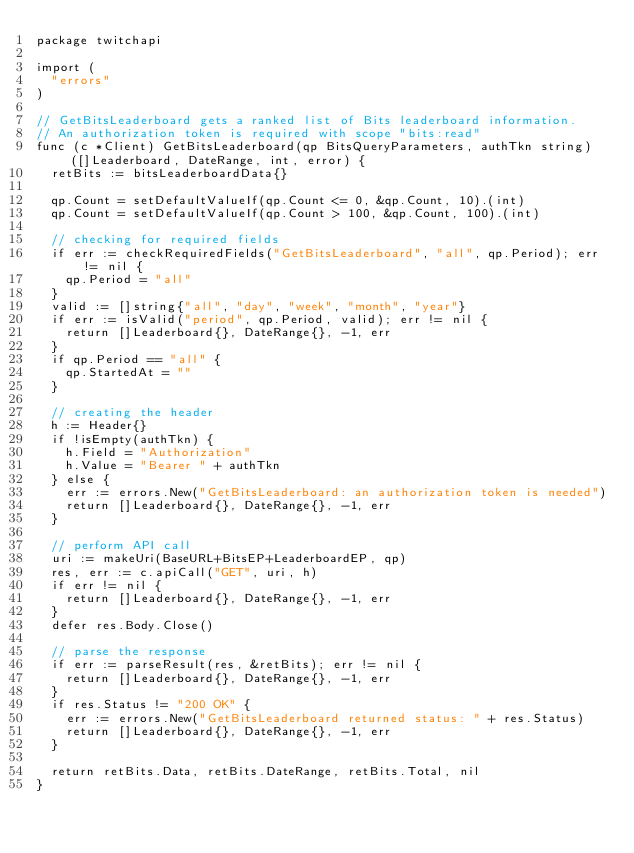<code> <loc_0><loc_0><loc_500><loc_500><_Go_>package twitchapi

import (
	"errors"
)

// GetBitsLeaderboard gets a ranked list of Bits leaderboard information.
// An authorization token is required with scope "bits:read"
func (c *Client) GetBitsLeaderboard(qp BitsQueryParameters, authTkn string) ([]Leaderboard, DateRange, int, error) {
	retBits := bitsLeaderboardData{}

	qp.Count = setDefaultValueIf(qp.Count <= 0, &qp.Count, 10).(int)
	qp.Count = setDefaultValueIf(qp.Count > 100, &qp.Count, 100).(int)

	// checking for required fields
	if err := checkRequiredFields("GetBitsLeaderboard", "all", qp.Period); err != nil {
		qp.Period = "all"
	}
	valid := []string{"all", "day", "week", "month", "year"}
	if err := isValid("period", qp.Period, valid); err != nil {
		return []Leaderboard{}, DateRange{}, -1, err
	}
	if qp.Period == "all" {
		qp.StartedAt = ""
	}

	// creating the header
	h := Header{}
	if !isEmpty(authTkn) {
		h.Field = "Authorization"
		h.Value = "Bearer " + authTkn
	} else {
		err := errors.New("GetBitsLeaderboard: an authorization token is needed")
		return []Leaderboard{}, DateRange{}, -1, err
	}

	// perform API call
	uri := makeUri(BaseURL+BitsEP+LeaderboardEP, qp)
	res, err := c.apiCall("GET", uri, h)
	if err != nil {
		return []Leaderboard{}, DateRange{}, -1, err
	}
	defer res.Body.Close()

	// parse the response
	if err := parseResult(res, &retBits); err != nil {
		return []Leaderboard{}, DateRange{}, -1, err
	}
	if res.Status != "200 OK" {
		err := errors.New("GetBitsLeaderboard returned status: " + res.Status)
		return []Leaderboard{}, DateRange{}, -1, err
	}

	return retBits.Data, retBits.DateRange, retBits.Total, nil
}
</code> 